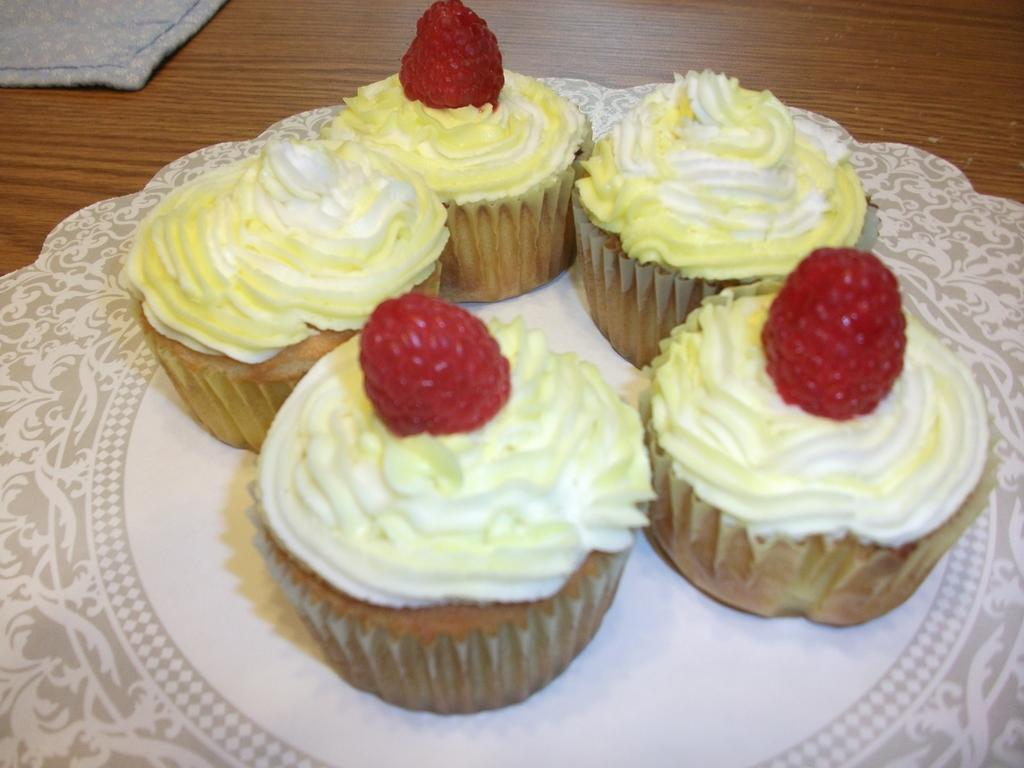What type of food can be seen in the image? There are muffins in the image. What is the cloth used for in the image? The cloth's purpose is not specified in the image. What is the plate used for in the image? The plate contains muffins in the image. What type of fruit is present in the image? There are berries in the image. What type of surface is visible in the image? The wooden surface is present in the image. How many boys are holding rifles in the image? There are no boys or rifles present in the image. 